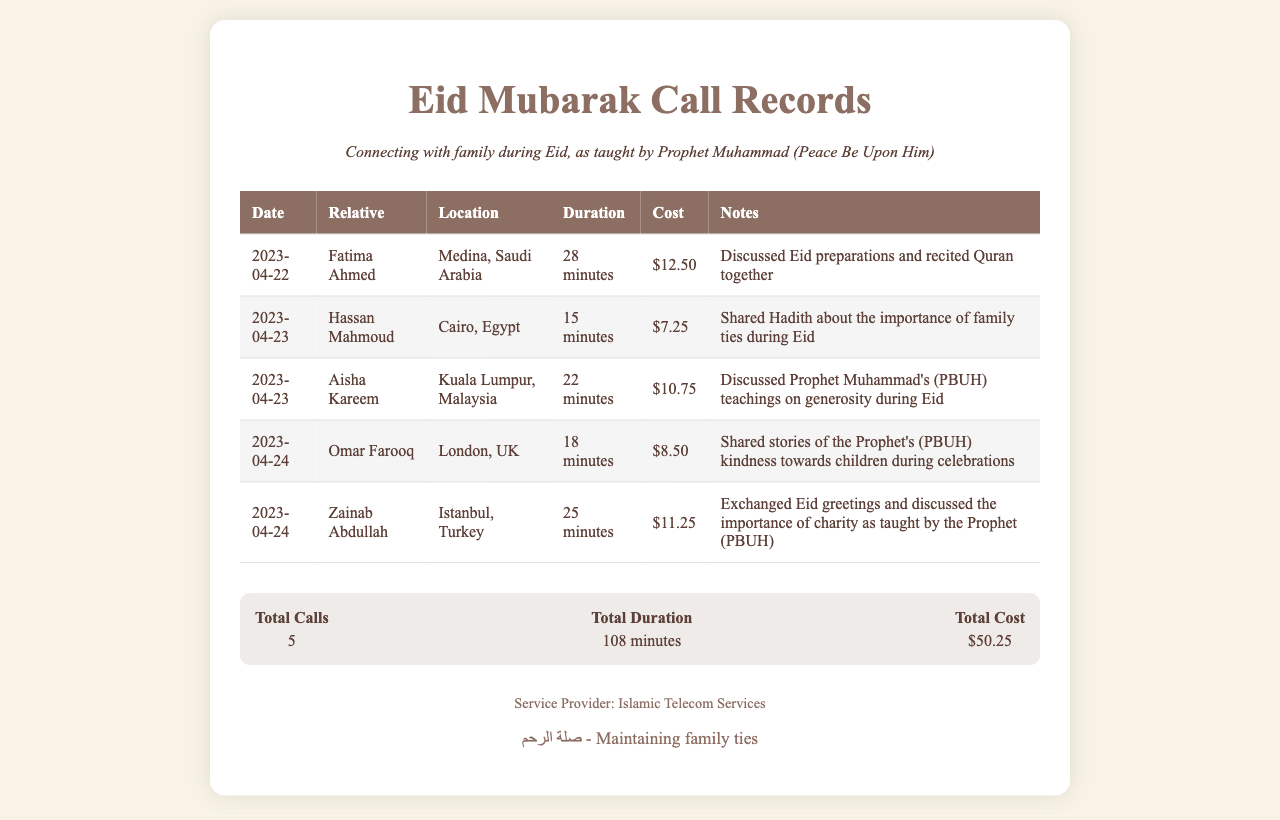What is the date of the first call? The first call was made on April 22, 2023, as noted at the top of the list.
Answer: April 22, 2023 Who is the relative called on April 23, 2023? On April 23, 2023, two calls were made; one was to Hassan Mahmoud and the other to Aisha Kareem.
Answer: Hassan Mahmoud and Aisha Kareem What was the total duration of all the calls? The total duration is calculated by adding the duration of each call together, which sums to 108 minutes.
Answer: 108 minutes What is the cost of the call to Zainab Abdullah? The cost for the call to Zainab Abdullah is listed explicitly in the table.
Answer: $11.25 How many calls were made to relatives located outside of the Arabic region? The record shows calls made to relatives in Malaysia, the UK, and Turkey, which are all outside the Arabic region.
Answer: 3 What was discussed during the call with Omar Farooq? The call with Omar Farooq included sharing stories about the Prophet's kindness towards children during celebrations.
Answer: Prophet's kindness towards children What is the total cost of all calls combined? The total cost is provided at the end of the call records, summing to $50.25.
Answer: $50.25 What is the location of Fatima Ahmed? Fatima Ahmed's location is listed in the document next to her name.
Answer: Medina, Saudi Arabia What does the footer of the document emphasize? The footer contains a phrase emphasizing the importance of maintaining family ties, which is significant in the context of the document.
Answer: Maintaining family ties 